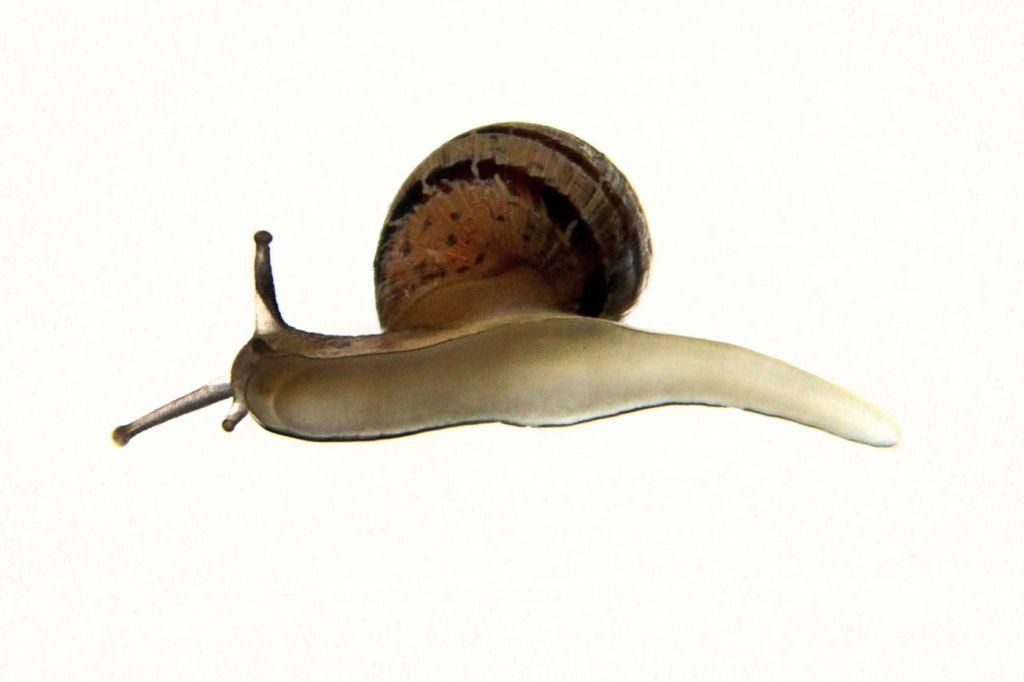What type of animal is present in the image? There is a snail in the image. What nation is the snail representing in the image? The image does not depict the snail representing any nation. Can you touch the snail in the image? You cannot touch the snail in the image, as it is a two-dimensional representation. 